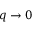<formula> <loc_0><loc_0><loc_500><loc_500>q \rightarrow 0</formula> 